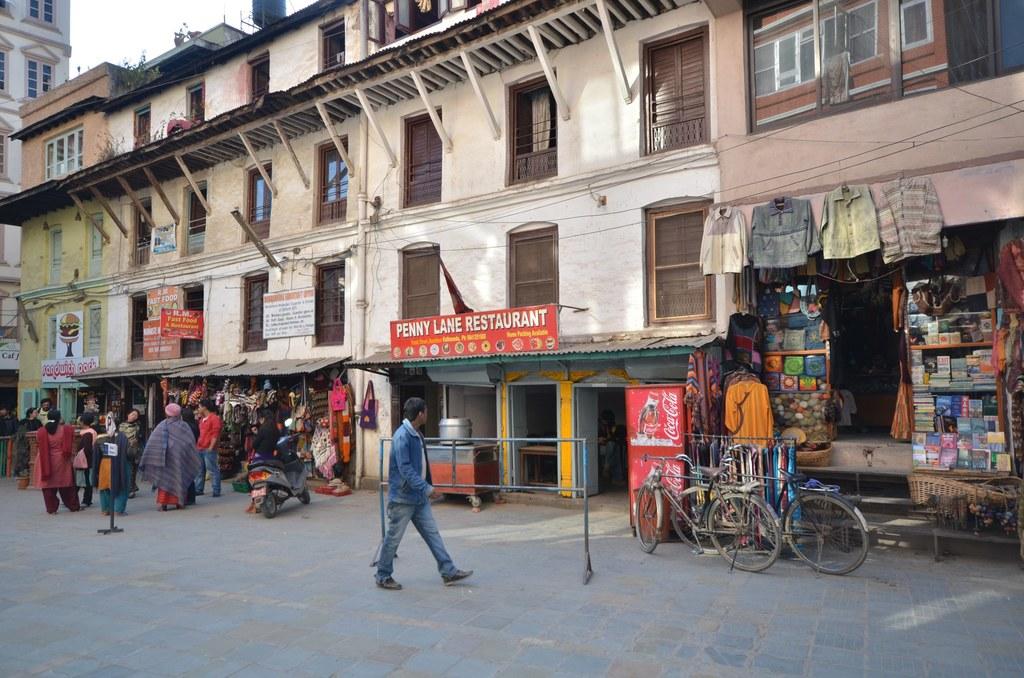What is the name of the restaurant shown?
Your answer should be compact. Penny lane restaurant . What soft drink company sign is beside the bicycles?
Your answer should be compact. Coca cola. 